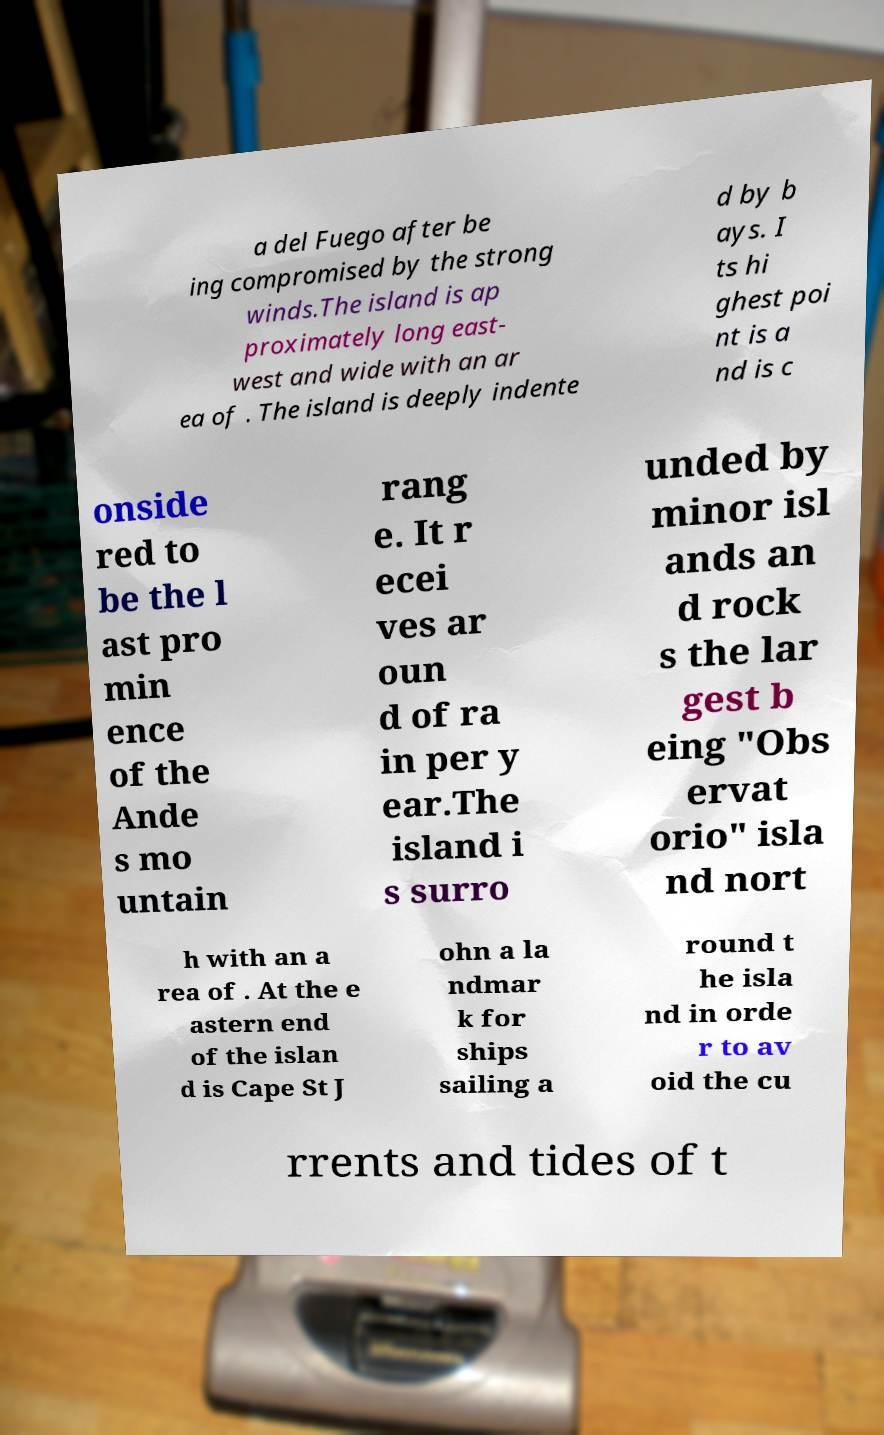Can you read and provide the text displayed in the image?This photo seems to have some interesting text. Can you extract and type it out for me? a del Fuego after be ing compromised by the strong winds.The island is ap proximately long east- west and wide with an ar ea of . The island is deeply indente d by b ays. I ts hi ghest poi nt is a nd is c onside red to be the l ast pro min ence of the Ande s mo untain rang e. It r ecei ves ar oun d of ra in per y ear.The island i s surro unded by minor isl ands an d rock s the lar gest b eing "Obs ervat orio" isla nd nort h with an a rea of . At the e astern end of the islan d is Cape St J ohn a la ndmar k for ships sailing a round t he isla nd in orde r to av oid the cu rrents and tides of t 